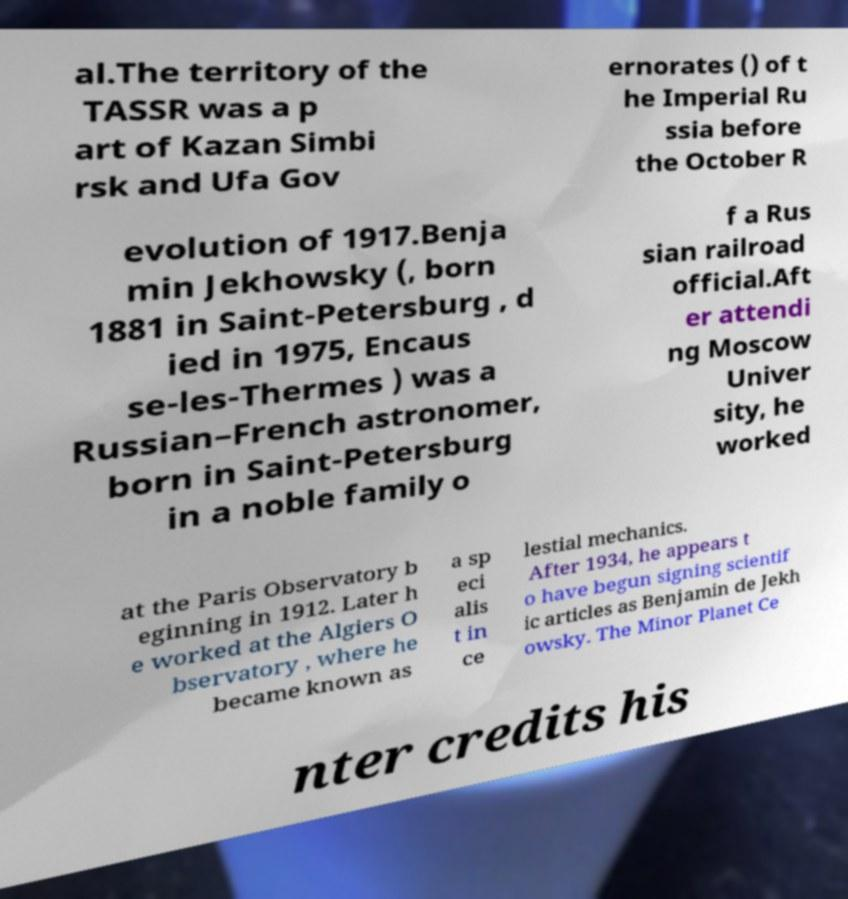Can you read and provide the text displayed in the image?This photo seems to have some interesting text. Can you extract and type it out for me? al.The territory of the TASSR was a p art of Kazan Simbi rsk and Ufa Gov ernorates () of t he Imperial Ru ssia before the October R evolution of 1917.Benja min Jekhowsky (, born 1881 in Saint-Petersburg , d ied in 1975, Encaus se-les-Thermes ) was a Russian–French astronomer, born in Saint-Petersburg in a noble family o f a Rus sian railroad official.Aft er attendi ng Moscow Univer sity, he worked at the Paris Observatory b eginning in 1912. Later h e worked at the Algiers O bservatory , where he became known as a sp eci alis t in ce lestial mechanics. After 1934, he appears t o have begun signing scientif ic articles as Benjamin de Jekh owsky. The Minor Planet Ce nter credits his 